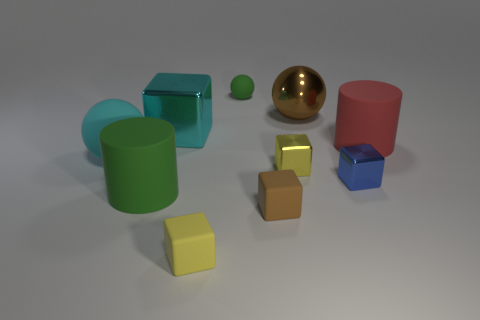Is the shape of the green thing behind the large cyan metal cube the same as the matte thing that is to the right of the small blue block?
Ensure brevity in your answer.  No. There is a matte object that is the same color as the large metal cube; what is its size?
Make the answer very short. Large. There is a small ball; is its color the same as the object that is right of the tiny blue object?
Give a very brief answer. No. Is the number of red matte things right of the large green cylinder less than the number of blocks in front of the blue metallic object?
Offer a terse response. Yes. What is the color of the ball that is both in front of the green rubber ball and to the right of the large cyan ball?
Offer a terse response. Brown. Is the size of the yellow matte thing the same as the cylinder on the right side of the yellow metallic cube?
Provide a short and direct response. No. What is the shape of the matte thing right of the small yellow shiny block?
Provide a short and direct response. Cylinder. There is a big cylinder left of the rubber cube in front of the tiny brown cube; what number of rubber things are to the left of it?
Make the answer very short. 1. There is a metal block that is behind the big rubber ball; is it the same size as the block on the right side of the brown metal sphere?
Give a very brief answer. No. There is a tiny yellow thing that is in front of the yellow block that is behind the green matte cylinder; what is it made of?
Your answer should be compact. Rubber. 